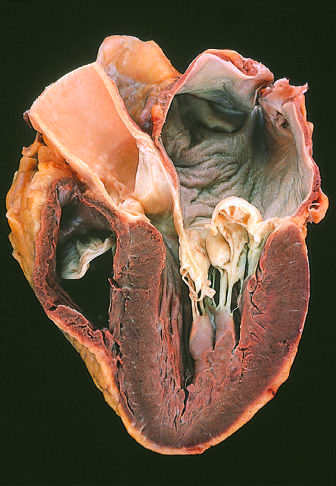where is the left ventricle shown in this four-chamber view?
Answer the question using a single word or phrase. On the right 